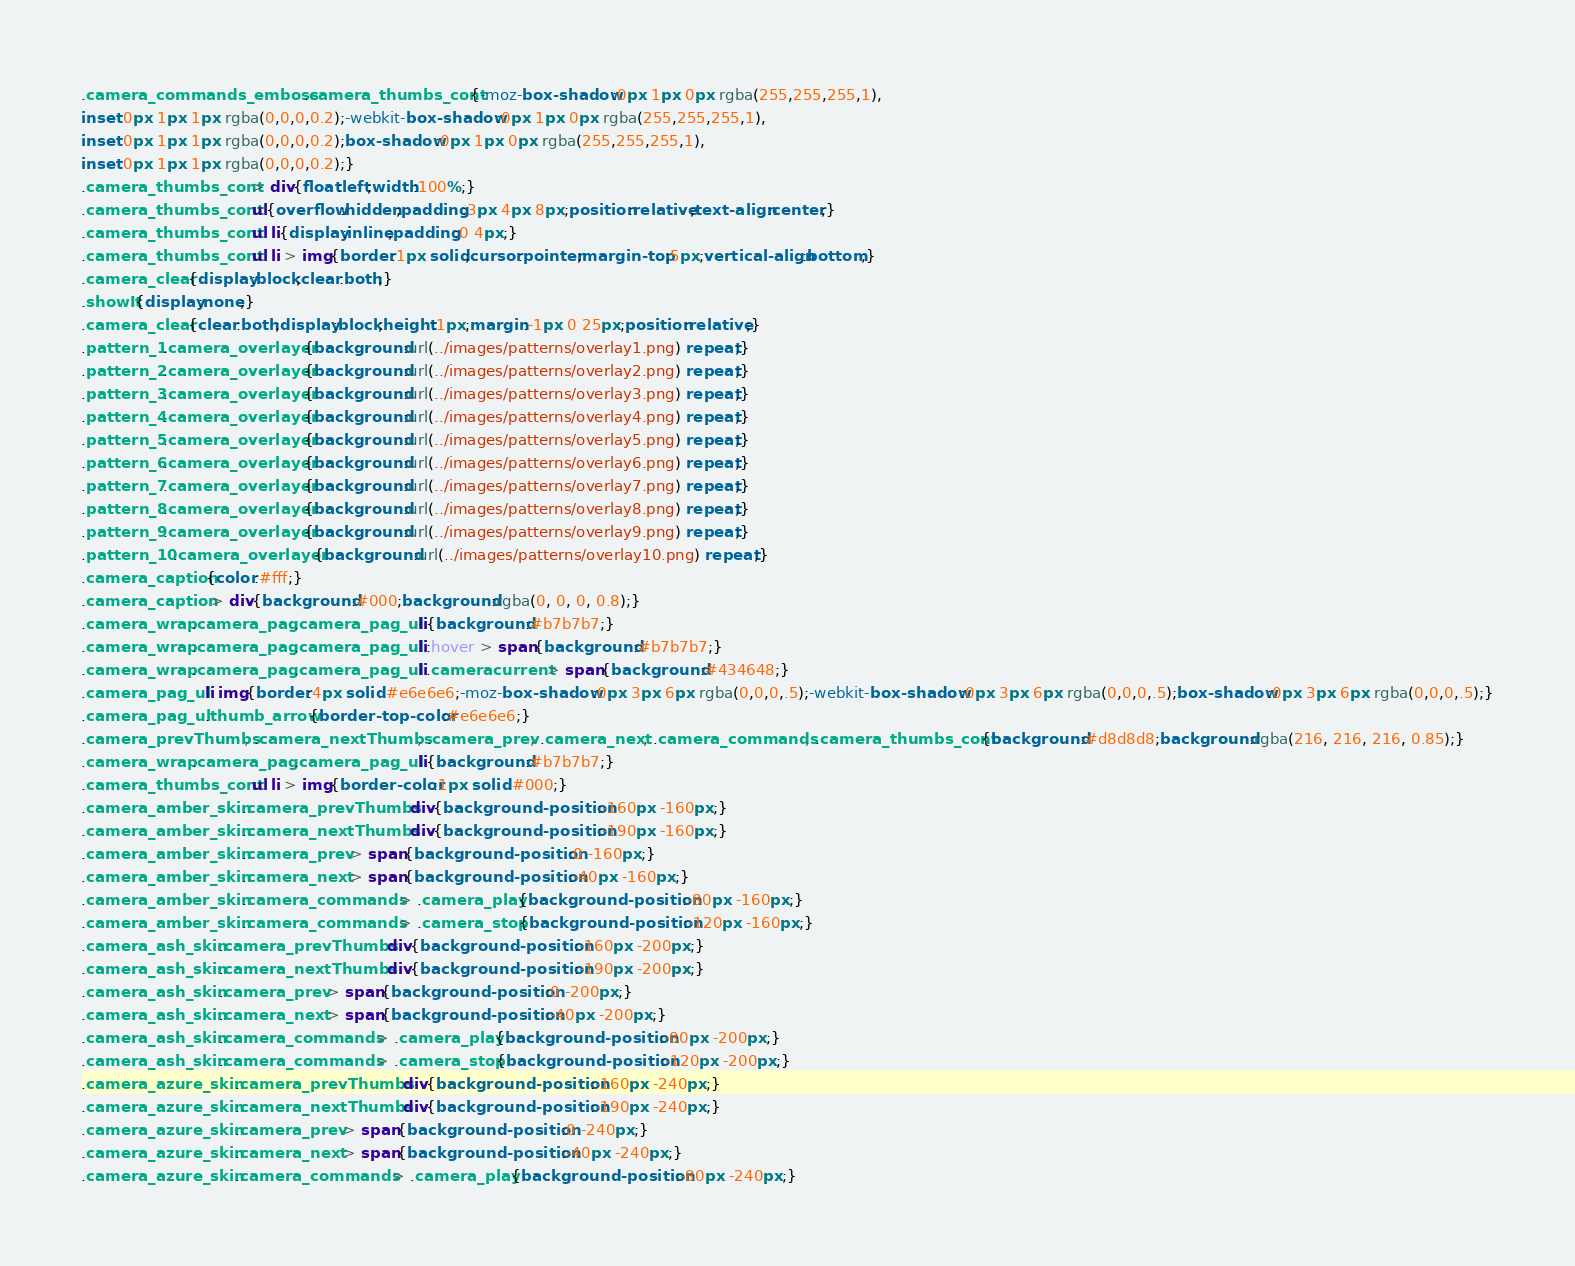<code> <loc_0><loc_0><loc_500><loc_500><_CSS_>.camera_commands_emboss .camera_thumbs_cont{-moz-box-shadow:0px 1px 0px rgba(255,255,255,1),
inset 0px 1px 1px rgba(0,0,0,0.2);-webkit-box-shadow:0px 1px 0px rgba(255,255,255,1),
inset 0px 1px 1px rgba(0,0,0,0.2);box-shadow:0px 1px 0px rgba(255,255,255,1),
inset 0px 1px 1px rgba(0,0,0,0.2);}
.camera_thumbs_cont > div{float:left;width:100%;}
.camera_thumbs_cont ul{overflow:hidden;padding:3px 4px 8px;position:relative;text-align:center;}
.camera_thumbs_cont ul li{display:inline;padding:0 4px;}
.camera_thumbs_cont ul li > img{border:1px solid;cursor:pointer;margin-top:5px;vertical-align:bottom;}
.camera_clear{display:block;clear:both;}
.showIt{display:none;}
.camera_clear{clear:both;display:block;height:1px;margin:-1px 0 25px;position:relative;}
.pattern_1 .camera_overlayer{background:url(../images/patterns/overlay1.png) repeat;}
.pattern_2 .camera_overlayer{background:url(../images/patterns/overlay2.png) repeat;}
.pattern_3 .camera_overlayer{background:url(../images/patterns/overlay3.png) repeat;}
.pattern_4 .camera_overlayer{background:url(../images/patterns/overlay4.png) repeat;}
.pattern_5 .camera_overlayer{background:url(../images/patterns/overlay5.png) repeat;}
.pattern_6 .camera_overlayer{background:url(../images/patterns/overlay6.png) repeat;}
.pattern_7 .camera_overlayer{background:url(../images/patterns/overlay7.png) repeat;}
.pattern_8 .camera_overlayer{background:url(../images/patterns/overlay8.png) repeat;}
.pattern_9 .camera_overlayer{background:url(../images/patterns/overlay9.png) repeat;}
.pattern_10 .camera_overlayer{background:url(../images/patterns/overlay10.png) repeat;}
.camera_caption{color:#fff;}
.camera_caption > div{background:#000;background:rgba(0, 0, 0, 0.8);}
.camera_wrap .camera_pag .camera_pag_ul li{background:#b7b7b7;}
.camera_wrap .camera_pag .camera_pag_ul li:hover > span{background:#b7b7b7;}
.camera_wrap .camera_pag .camera_pag_ul li.cameracurrent > span{background:#434648;}
.camera_pag_ul li img{border:4px solid #e6e6e6;-moz-box-shadow:0px 3px 6px rgba(0,0,0,.5);-webkit-box-shadow:0px 3px 6px rgba(0,0,0,.5);box-shadow:0px 3px 6px rgba(0,0,0,.5);}
.camera_pag_ul .thumb_arrow{border-top-color:#e6e6e6;}
.camera_prevThumbs, .camera_nextThumbs, .camera_prev, .camera_next, .camera_commands, .camera_thumbs_cont{background:#d8d8d8;background:rgba(216, 216, 216, 0.85);}
.camera_wrap .camera_pag .camera_pag_ul li{background:#b7b7b7;}
.camera_thumbs_cont ul li > img{border-color:1px solid #000;}
.camera_amber_skin .camera_prevThumbs div{background-position:-160px -160px;}
.camera_amber_skin .camera_nextThumbs div{background-position:-190px -160px;}
.camera_amber_skin .camera_prev > span{background-position:0 -160px;}
.camera_amber_skin .camera_next > span{background-position:-40px -160px;}
.camera_amber_skin .camera_commands > .camera_play{background-position:-80px -160px;}
.camera_amber_skin .camera_commands > .camera_stop{background-position:-120px -160px;}
.camera_ash_skin .camera_prevThumbs div{background-position:-160px -200px;}
.camera_ash_skin .camera_nextThumbs div{background-position:-190px -200px;}
.camera_ash_skin .camera_prev > span{background-position:0 -200px;}
.camera_ash_skin .camera_next > span{background-position:-40px -200px;}
.camera_ash_skin .camera_commands > .camera_play{background-position:-80px -200px;}
.camera_ash_skin .camera_commands > .camera_stop{background-position:-120px -200px;}
.camera_azure_skin .camera_prevThumbs div{background-position:-160px -240px;}
.camera_azure_skin .camera_nextThumbs div{background-position:-190px -240px;}
.camera_azure_skin .camera_prev > span{background-position:0 -240px;}
.camera_azure_skin .camera_next > span{background-position:-40px -240px;}
.camera_azure_skin .camera_commands > .camera_play{background-position:-80px -240px;}</code> 